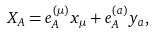<formula> <loc_0><loc_0><loc_500><loc_500>X _ { A } = e ^ { ( \mu ) } _ { A } x _ { \mu } + e ^ { ( a ) } _ { A } y _ { a } ,</formula> 